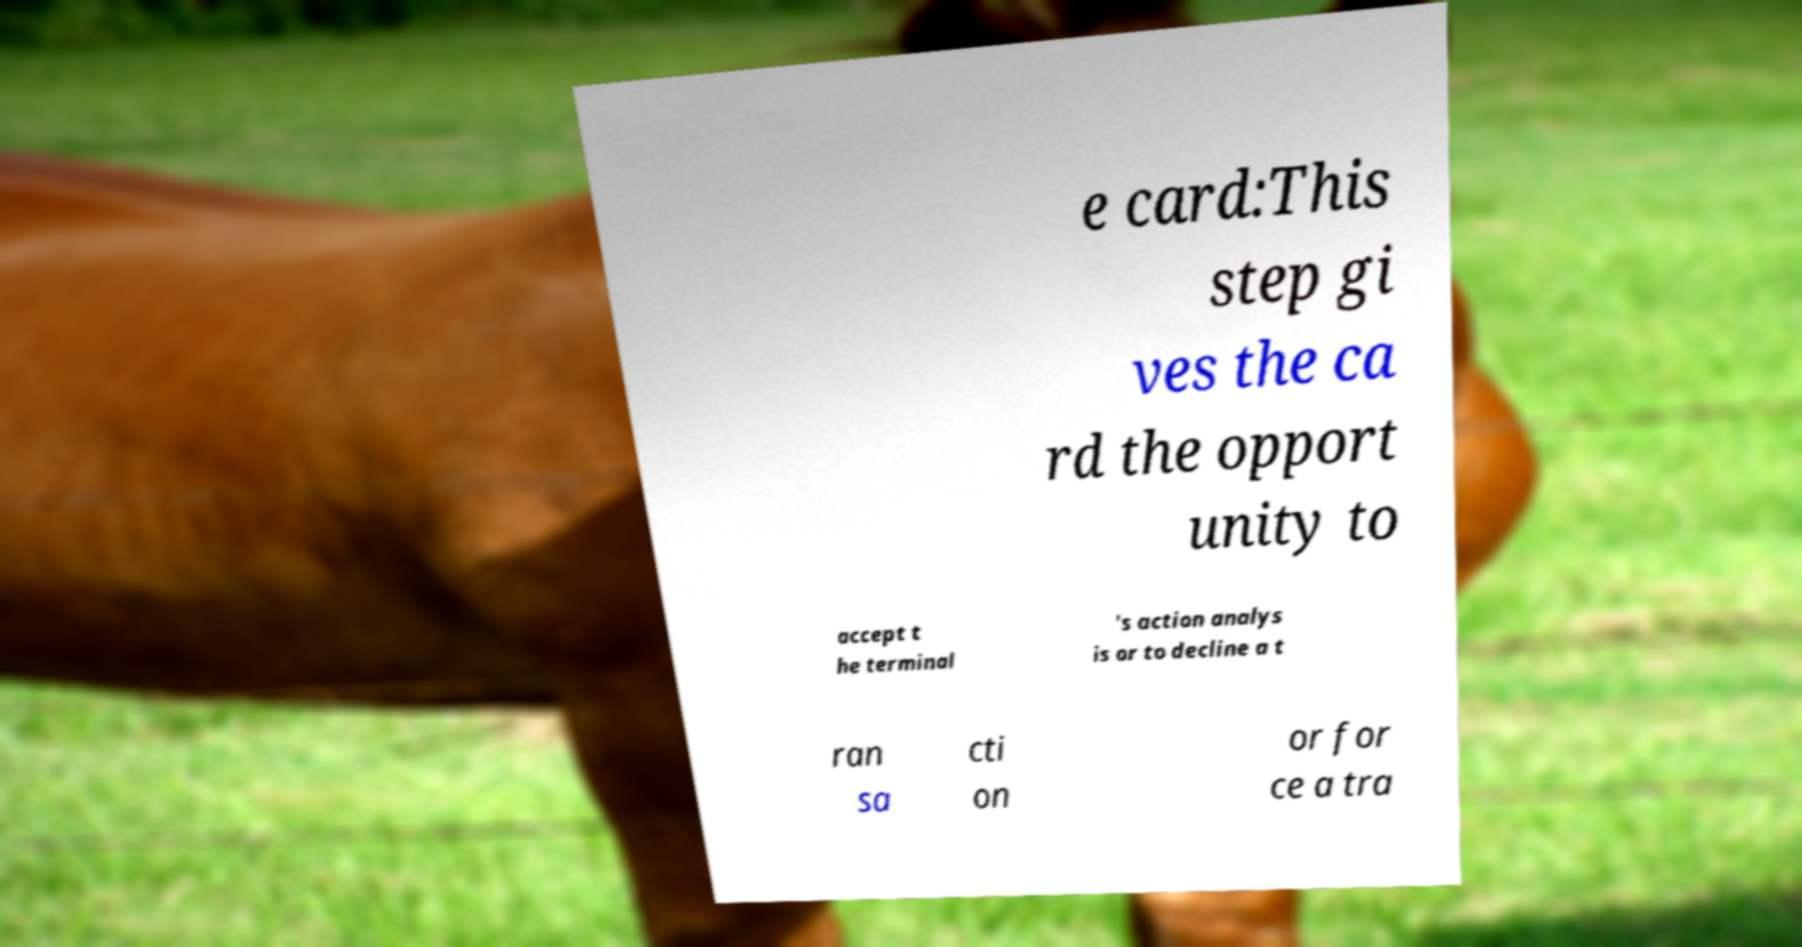Can you read and provide the text displayed in the image?This photo seems to have some interesting text. Can you extract and type it out for me? e card:This step gi ves the ca rd the opport unity to accept t he terminal 's action analys is or to decline a t ran sa cti on or for ce a tra 